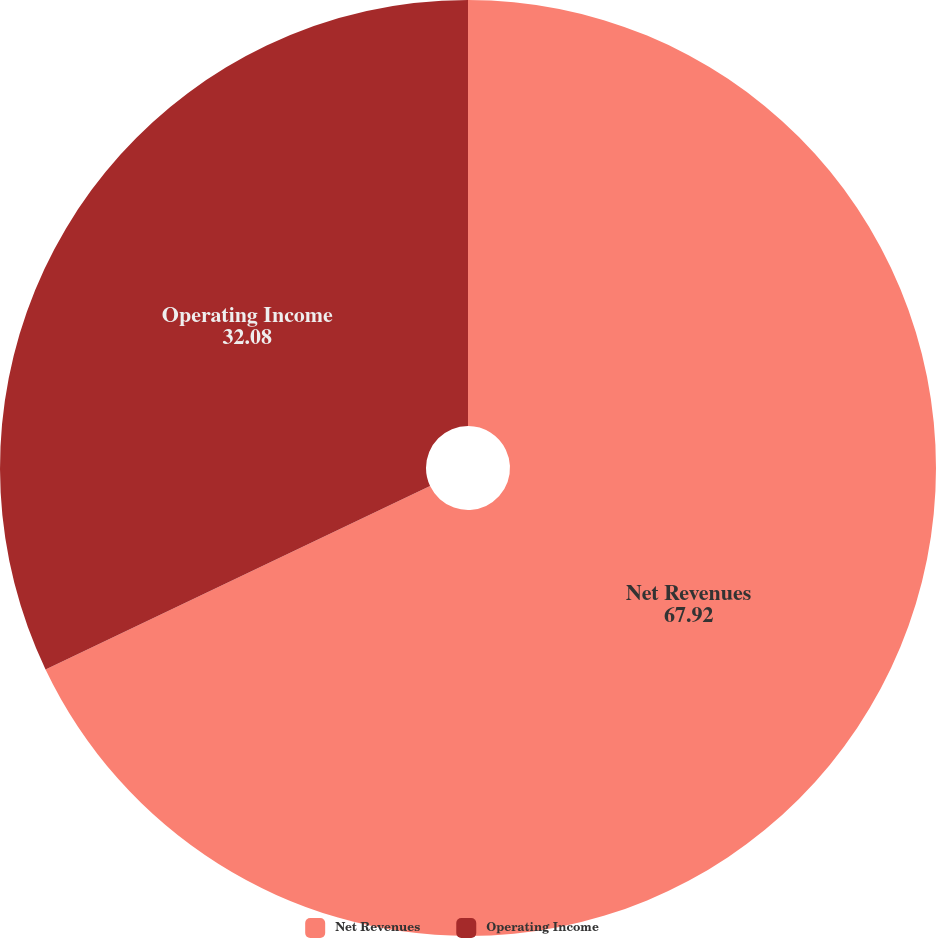Convert chart. <chart><loc_0><loc_0><loc_500><loc_500><pie_chart><fcel>Net Revenues<fcel>Operating Income<nl><fcel>67.92%<fcel>32.08%<nl></chart> 